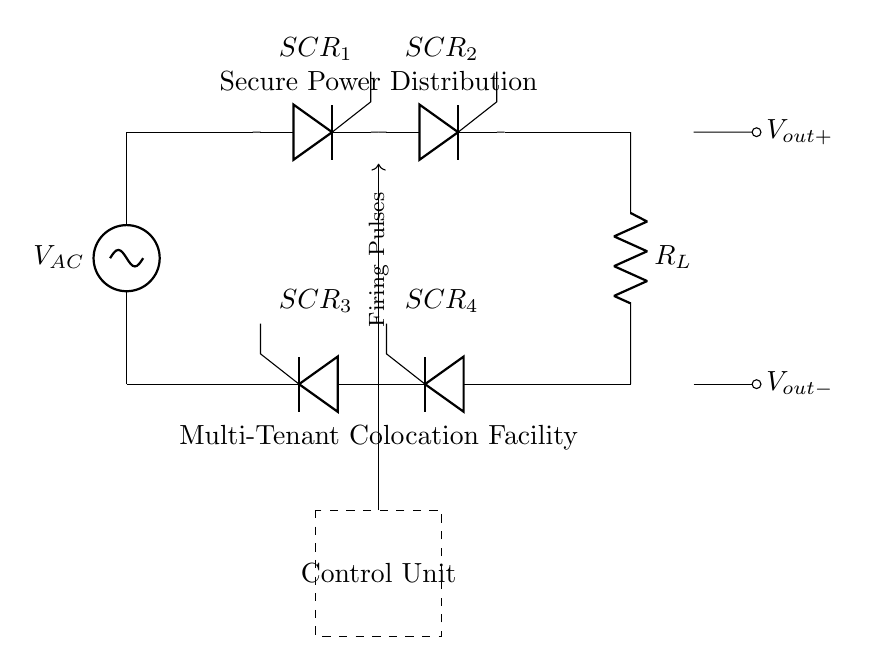What type of rectifier is shown in the circuit? The circuit illustrates a controlled rectifier, which is often referred to as a silicon-controlled rectifier (SCR) bridge. The components shown are specifically thyristors used for rectification.
Answer: controlled rectifier How many thyristors are present in this circuit? The diagram shows four thyristors labeled SCR_1, SCR_2, SCR_3, and SCR_4, indicating that there are four thyristors in total.
Answer: four What is the function of the control unit? The control unit is responsible for sending firing pulses to the thyristors, enabling control over their conduction states to regulate output voltage and current.
Answer: firing pulses What type of load is connected to the output? The load specified in the circuit diagram is a resistor, denoted by R_L, which serves as the electrical load receiving power from the rectifier.
Answer: resistor What is the input voltage type in this circuit? The circuit diagram identifies the input voltage as AC, indicated by the label V_AC at the top of the diagram, implying an alternating current source.
Answer: AC How does the configuration of thyristors influence power distribution? The series configuration of thyristors allows for control and management of the output voltage and current, effectively enabling safe power distribution for a multi-tenant environment.
Answer: power regulation What is indicated by the dashed rectangle in the circuit diagram? The dashed rectangle symbolizes the control unit, which houses the circuitry responsible for generating signals that trigger the thyristors at precise intervals to manage power delivery.
Answer: Control Unit 